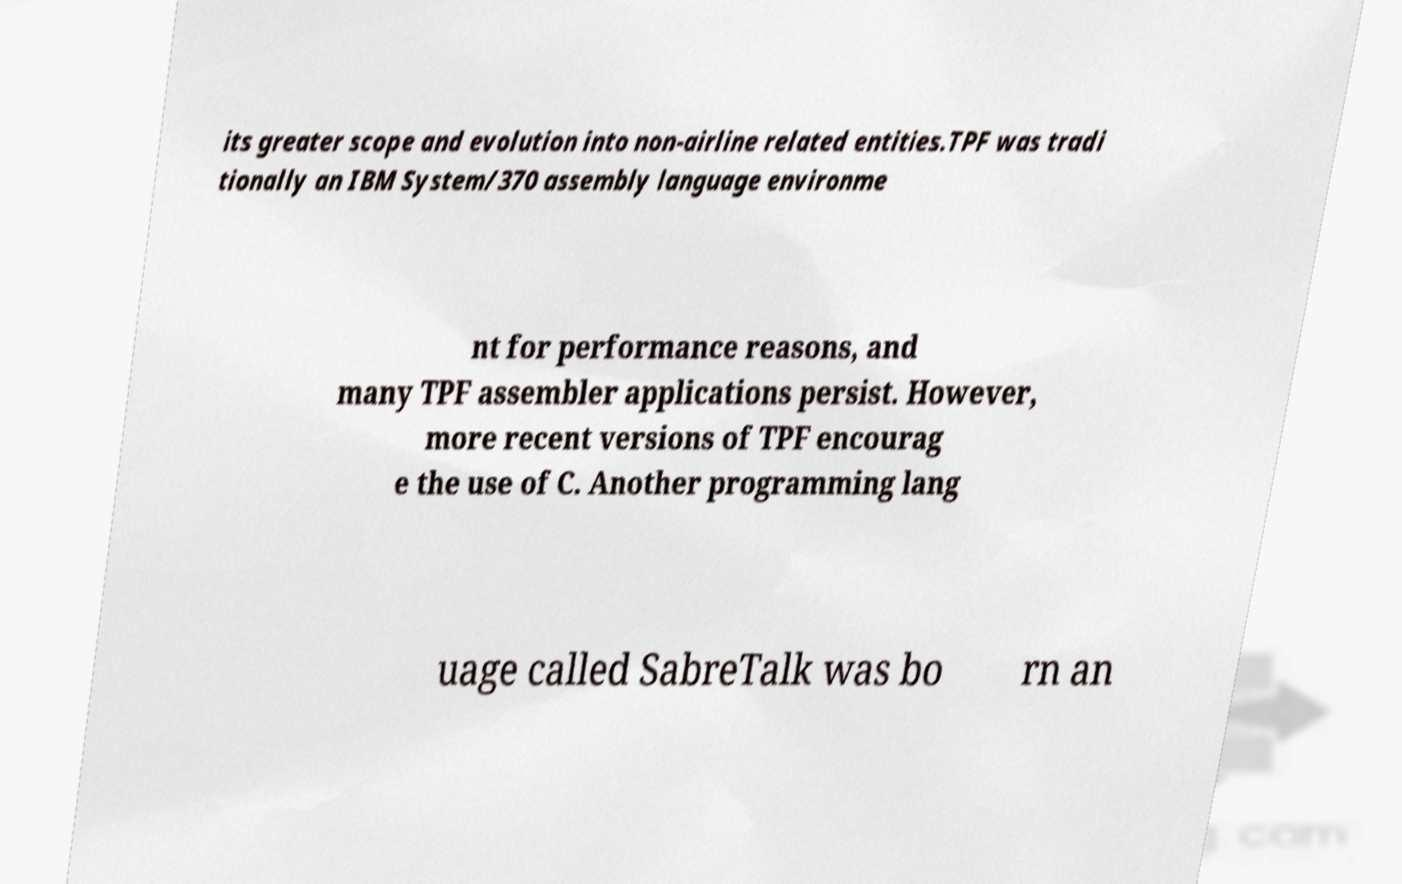Can you read and provide the text displayed in the image?This photo seems to have some interesting text. Can you extract and type it out for me? its greater scope and evolution into non-airline related entities.TPF was tradi tionally an IBM System/370 assembly language environme nt for performance reasons, and many TPF assembler applications persist. However, more recent versions of TPF encourag e the use of C. Another programming lang uage called SabreTalk was bo rn an 